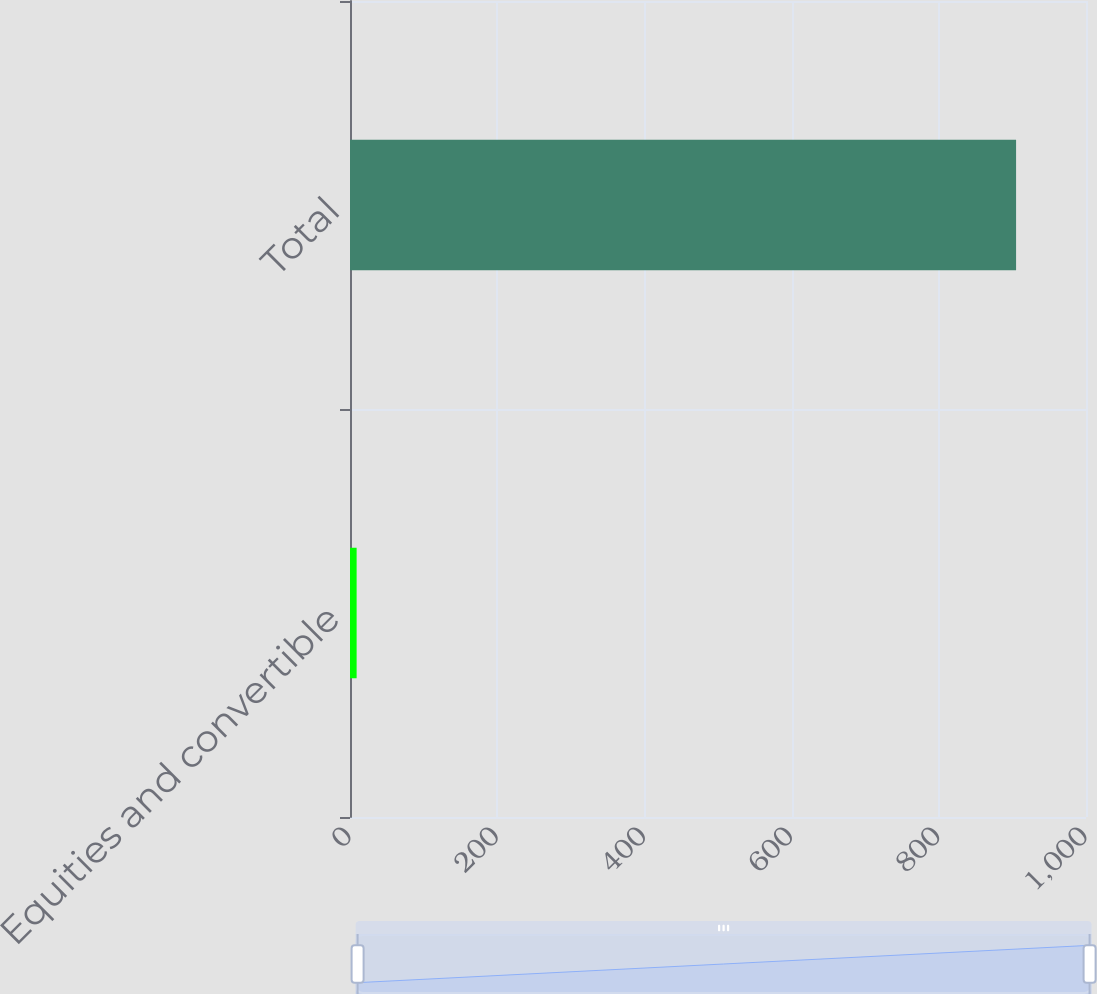Convert chart. <chart><loc_0><loc_0><loc_500><loc_500><bar_chart><fcel>Equities and convertible<fcel>Total<nl><fcel>9<fcel>905<nl></chart> 